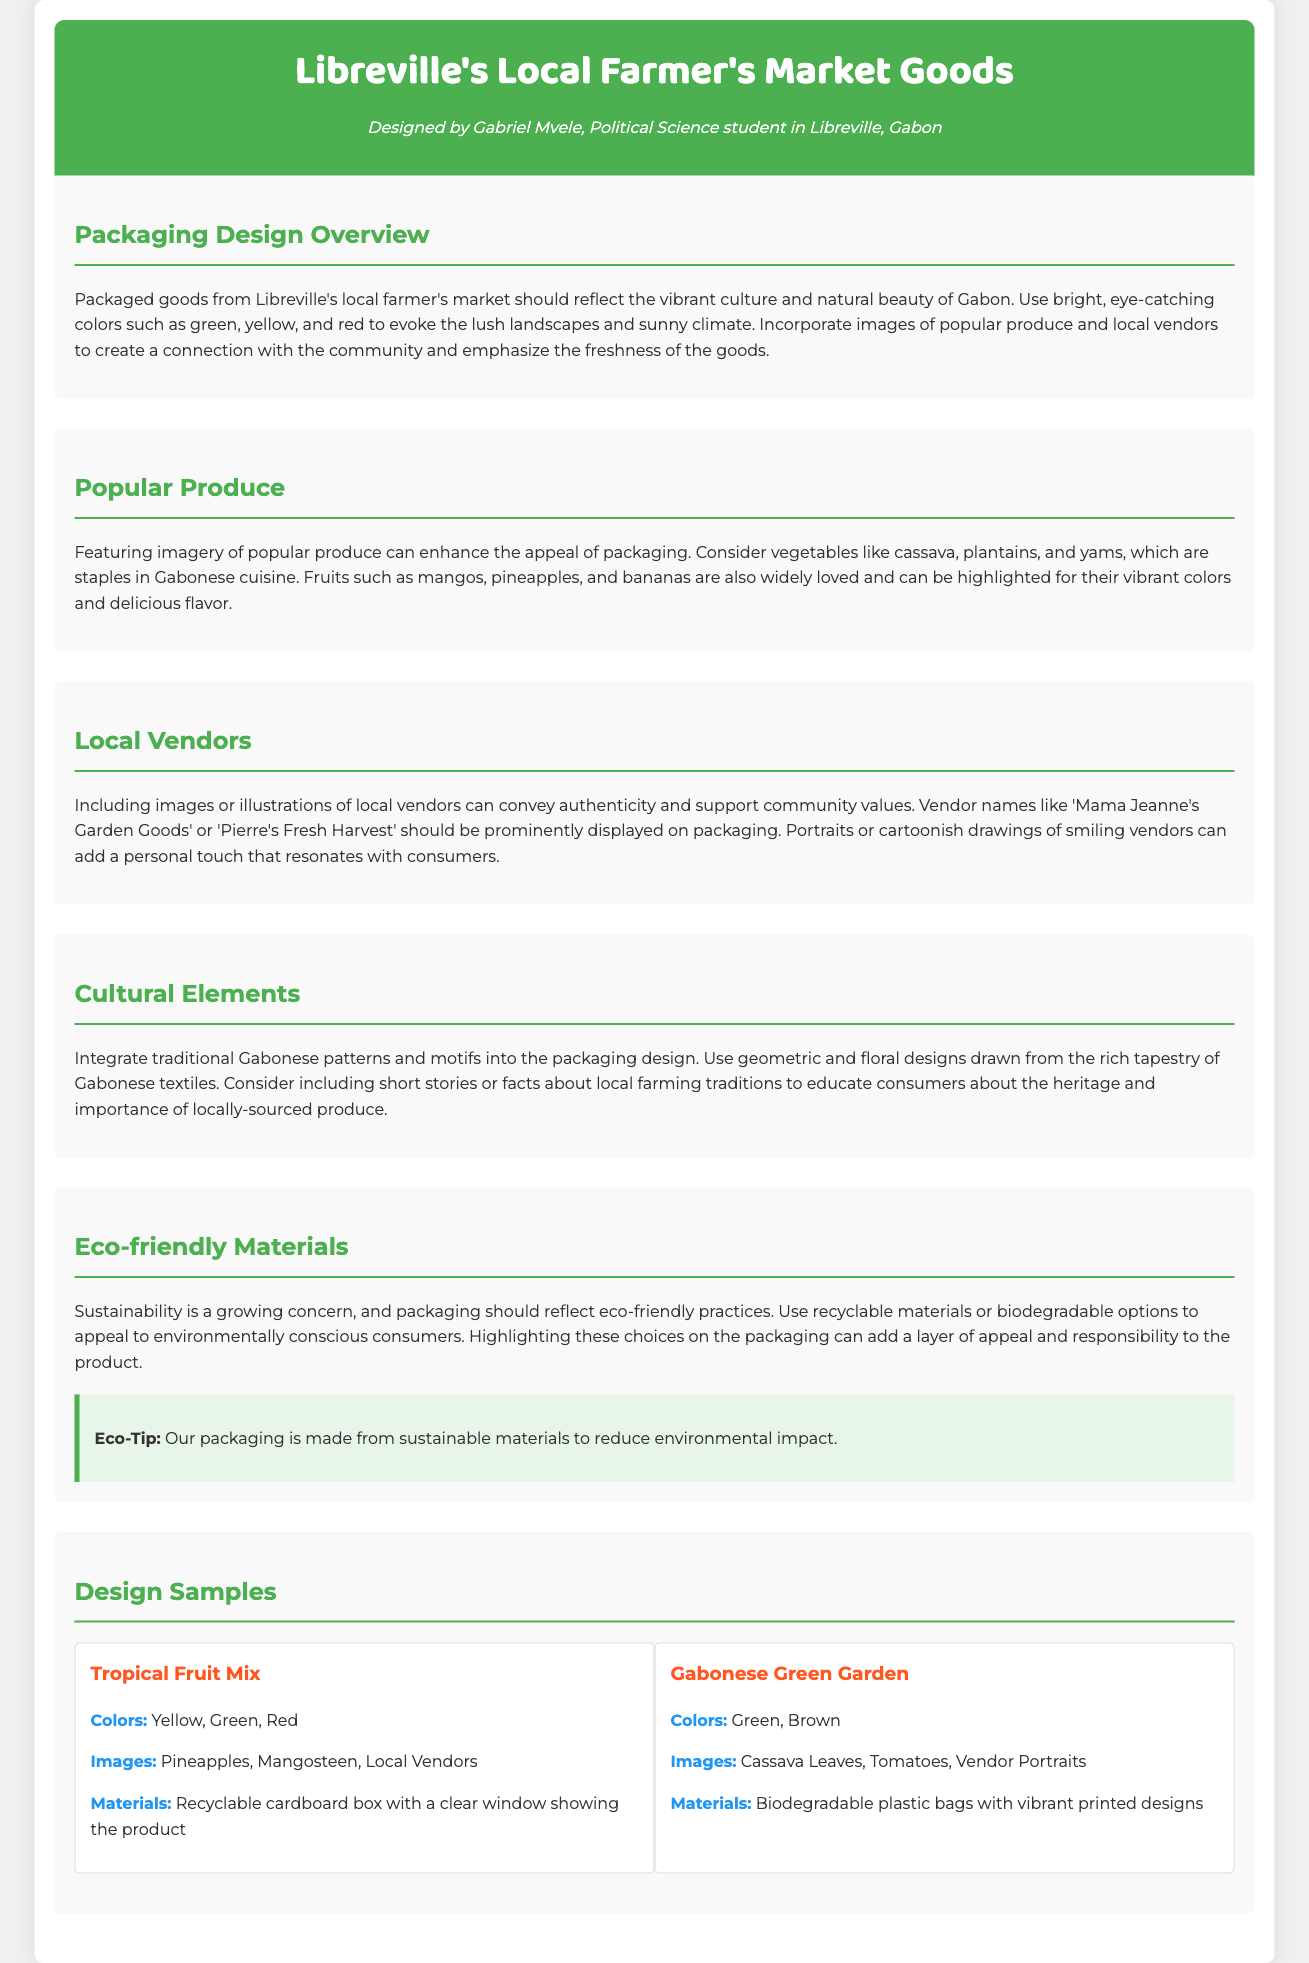what are the vibrant colors used in packaging design? The vibrant colors mentioned for packaging design are green, yellow, and red.
Answer: green, yellow, red which local vendors are highlighted on the packaging? The local vendors mentioned are 'Mama Jeanne's Garden Goods' and 'Pierre's Fresh Harvest'.
Answer: Mama Jeanne's Garden Goods, Pierre's Fresh Harvest what key produce is featured in the Tropical Fruit Mix design? The key produce for the Tropical Fruit Mix includes pineapples and mangosteen.
Answer: pineapples, mangosteen what type of materials are suggested for eco-friendly packaging? The suggested materials for eco-friendly packaging include recyclable and biodegradable options.
Answer: recyclable, biodegradable how many design samples are included in the document? The document includes two design samples.
Answer: two what traditional elements should be incorporated into the packaging design? The packaging design should incorporate traditional Gabonese patterns and motifs.
Answer: traditional Gabonese patterns and motifs what is one of the eco-tips provided in the packaging design? The eco-tip given emphasizes that the packaging is made from sustainable materials to reduce environmental impact.
Answer: sustainable materials what is the primary target of the packaging design's color scheme? The primary target of the color scheme is to evoke the lush landscapes and sunny climate of Gabon.
Answer: lush landscapes and sunny climate 